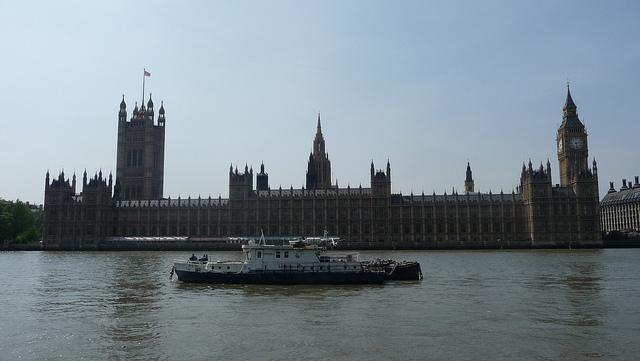How many buildings are in the background?
Give a very brief answer. 2. How many boats are visible?
Give a very brief answer. 1. How many boats can you see?
Give a very brief answer. 1. How many people are wearing an ascot?
Give a very brief answer. 0. 